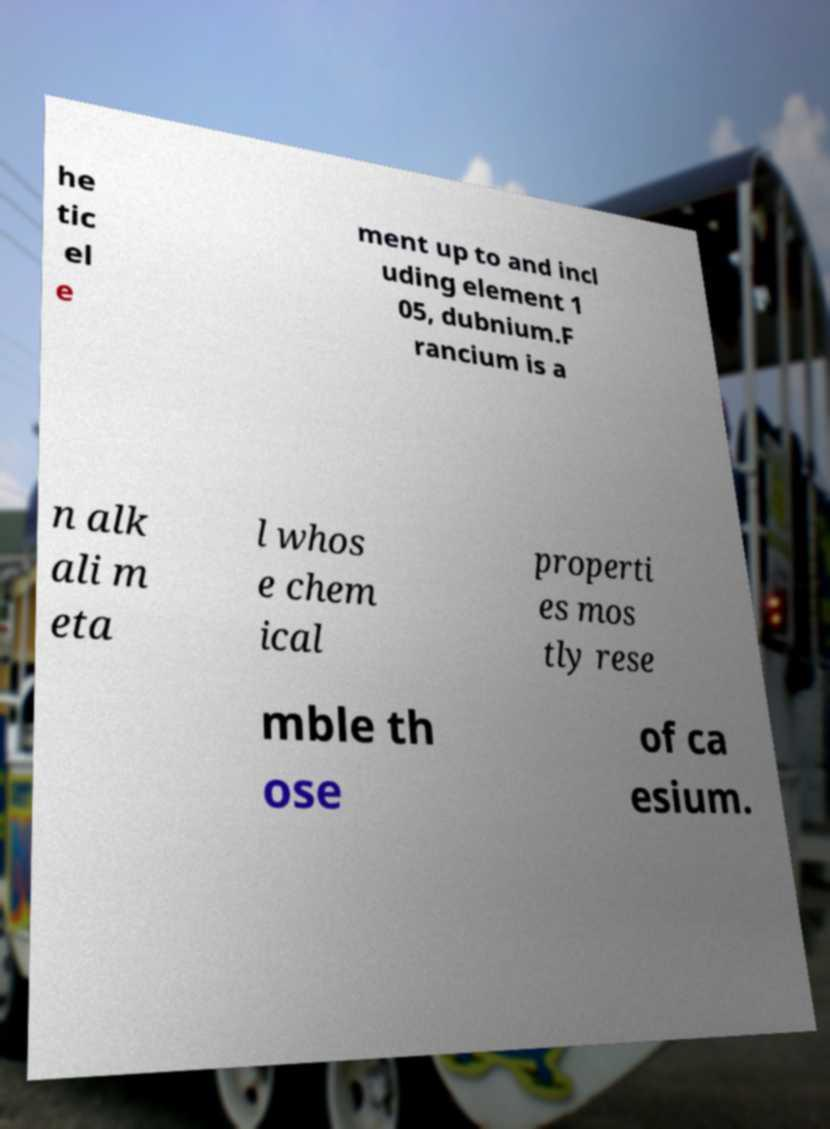Could you assist in decoding the text presented in this image and type it out clearly? he tic el e ment up to and incl uding element 1 05, dubnium.F rancium is a n alk ali m eta l whos e chem ical properti es mos tly rese mble th ose of ca esium. 